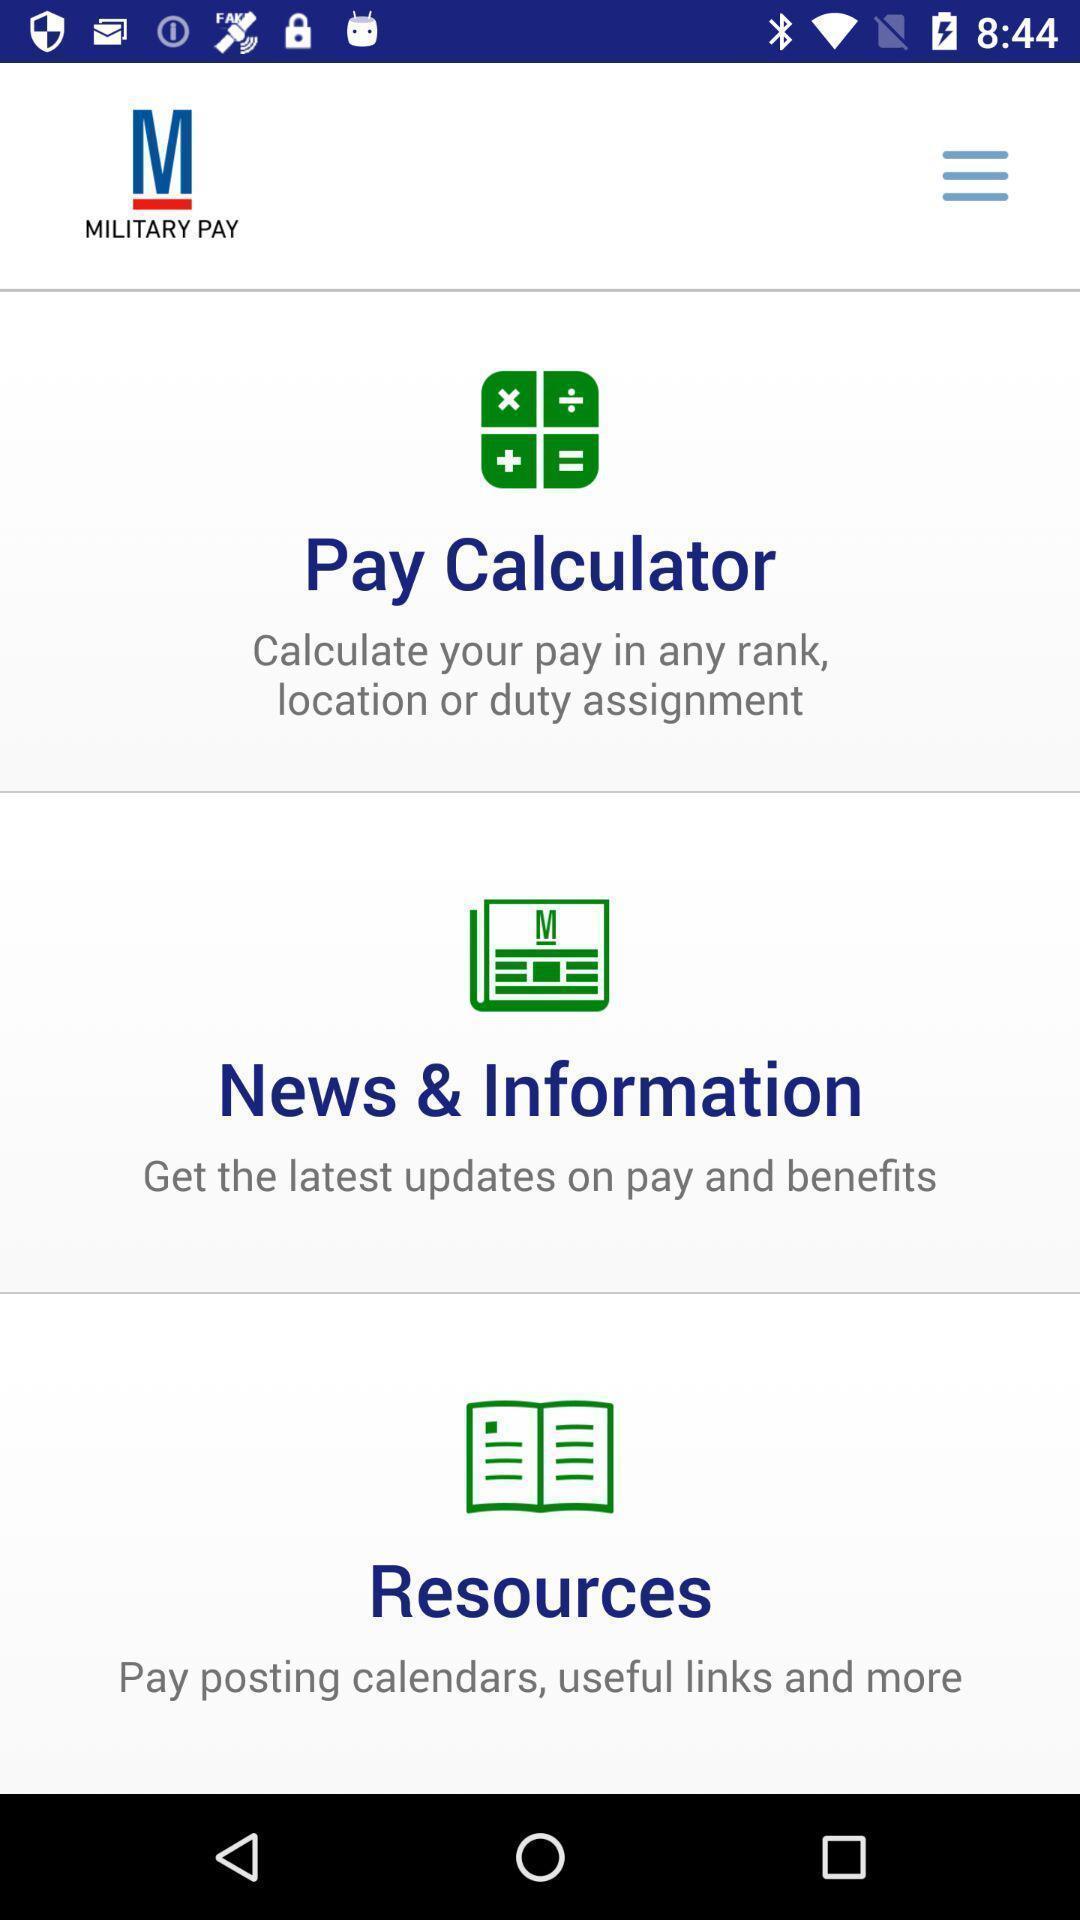Describe the content in this image. Screen shows multiple options in a financial application. 